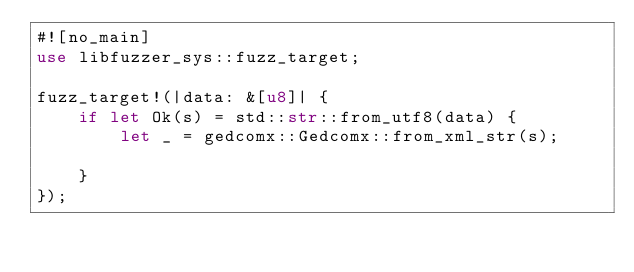Convert code to text. <code><loc_0><loc_0><loc_500><loc_500><_Rust_>#![no_main]
use libfuzzer_sys::fuzz_target;

fuzz_target!(|data: &[u8]| {
    if let Ok(s) = std::str::from_utf8(data) {
        let _ = gedcomx::Gedcomx::from_xml_str(s);

    }
});</code> 